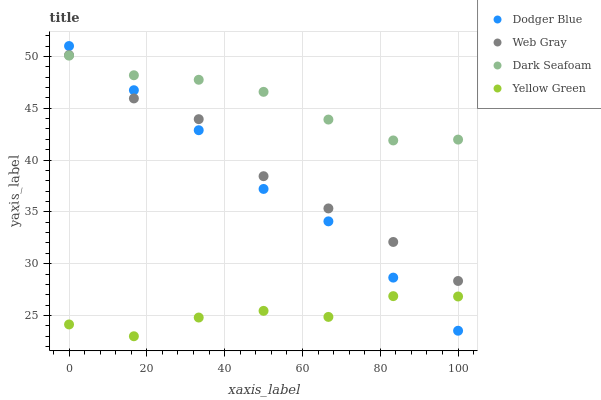Does Yellow Green have the minimum area under the curve?
Answer yes or no. Yes. Does Dark Seafoam have the maximum area under the curve?
Answer yes or no. Yes. Does Web Gray have the minimum area under the curve?
Answer yes or no. No. Does Web Gray have the maximum area under the curve?
Answer yes or no. No. Is Dark Seafoam the smoothest?
Answer yes or no. Yes. Is Yellow Green the roughest?
Answer yes or no. Yes. Is Web Gray the smoothest?
Answer yes or no. No. Is Web Gray the roughest?
Answer yes or no. No. Does Yellow Green have the lowest value?
Answer yes or no. Yes. Does Web Gray have the lowest value?
Answer yes or no. No. Does Dodger Blue have the highest value?
Answer yes or no. Yes. Does Web Gray have the highest value?
Answer yes or no. No. Is Yellow Green less than Web Gray?
Answer yes or no. Yes. Is Web Gray greater than Yellow Green?
Answer yes or no. Yes. Does Dodger Blue intersect Web Gray?
Answer yes or no. Yes. Is Dodger Blue less than Web Gray?
Answer yes or no. No. Is Dodger Blue greater than Web Gray?
Answer yes or no. No. Does Yellow Green intersect Web Gray?
Answer yes or no. No. 